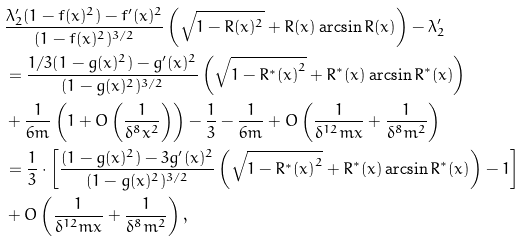Convert formula to latex. <formula><loc_0><loc_0><loc_500><loc_500>& \frac { \lambda _ { 2 } ^ { \prime } ( 1 - f ( x ) ^ { 2 } ) - f ^ { \prime } ( x ) ^ { 2 } } { ( 1 - f ( x ) ^ { 2 } ) ^ { 3 / 2 } } \left ( \sqrt { 1 - R ( x ) ^ { 2 } } + R ( x ) \arcsin { R ( x ) } \right ) - \lambda _ { 2 } ^ { \prime } \\ & = \frac { 1 / 3 ( 1 - g ( x ) ^ { 2 } ) - g ^ { \prime } ( x ) ^ { 2 } } { ( 1 - g ( x ) ^ { 2 } ) ^ { 3 / 2 } } \left ( \sqrt { 1 - { R ^ { * } ( x ) } ^ { 2 } } + { R ^ { * } ( x ) } \arcsin { R ^ { * } ( x ) } \right ) \\ & + \frac { 1 } { 6 m } \left ( 1 + O \left ( \frac { 1 } { \delta ^ { 8 } x ^ { 2 } } \right ) \right ) - \frac { 1 } { 3 } - \frac { 1 } { 6 m } + O \left ( \frac { 1 } { \delta ^ { 1 2 } m x } + \frac { 1 } { \delta ^ { 8 } m ^ { 2 } } \right ) \\ & = \frac { 1 } { 3 } \cdot \left [ \frac { ( 1 - g ( x ) ^ { 2 } ) - 3 g ^ { \prime } ( x ) ^ { 2 } } { ( 1 - g ( x ) ^ { 2 } ) ^ { 3 / 2 } } \left ( \sqrt { 1 - { R ^ { * } ( x ) } ^ { 2 } } + { R ^ { * } ( x ) } \arcsin { R ^ { * } ( x ) } \right ) - 1 \right ] \\ & + O \left ( \frac { 1 } { \delta ^ { 1 2 } m x } + \frac { 1 } { \delta ^ { 8 } m ^ { 2 } } \right ) ,</formula> 